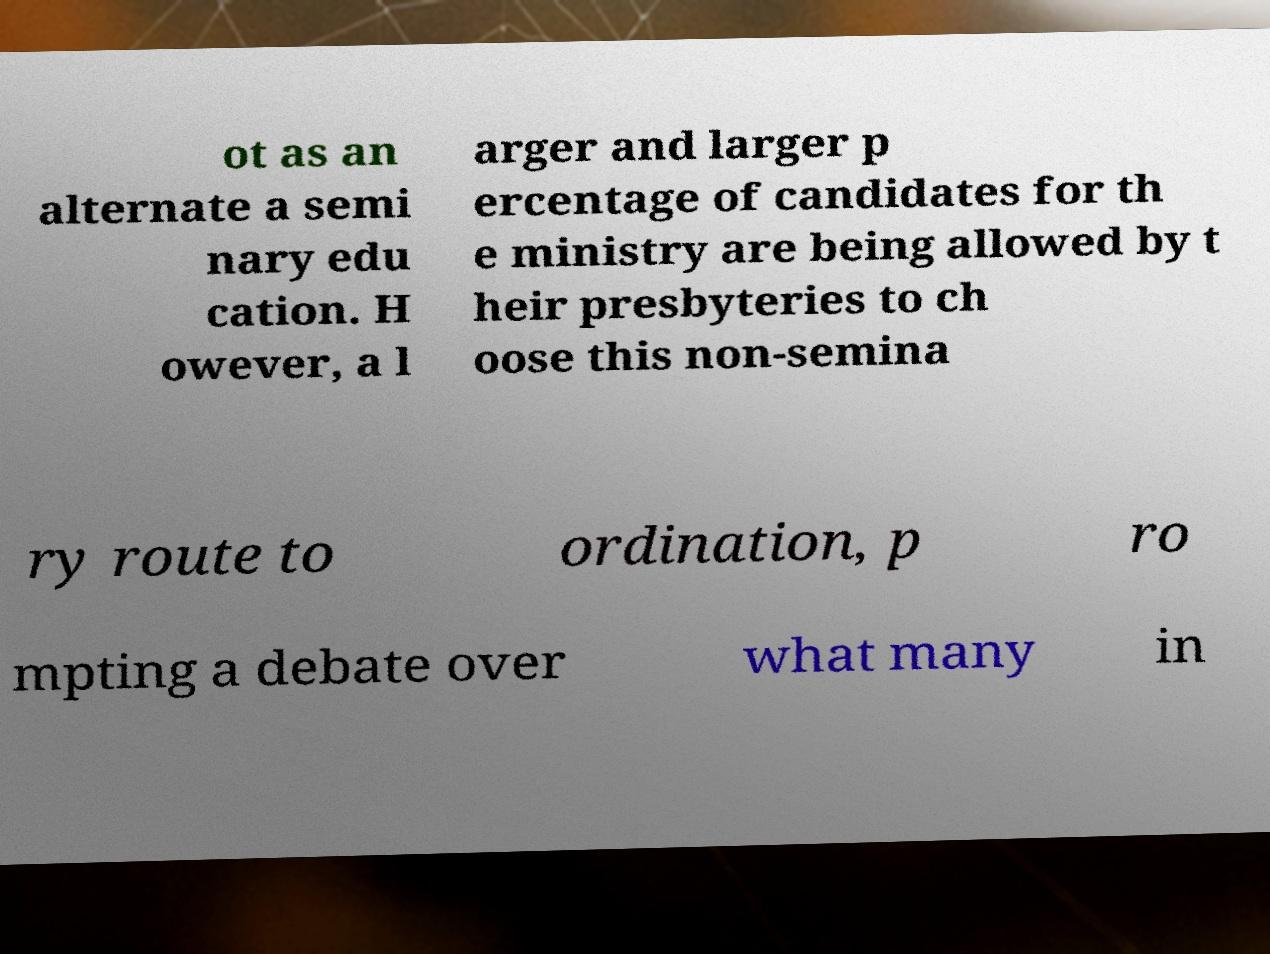For documentation purposes, I need the text within this image transcribed. Could you provide that? ot as an alternate a semi nary edu cation. H owever, a l arger and larger p ercentage of candidates for th e ministry are being allowed by t heir presbyteries to ch oose this non-semina ry route to ordination, p ro mpting a debate over what many in 